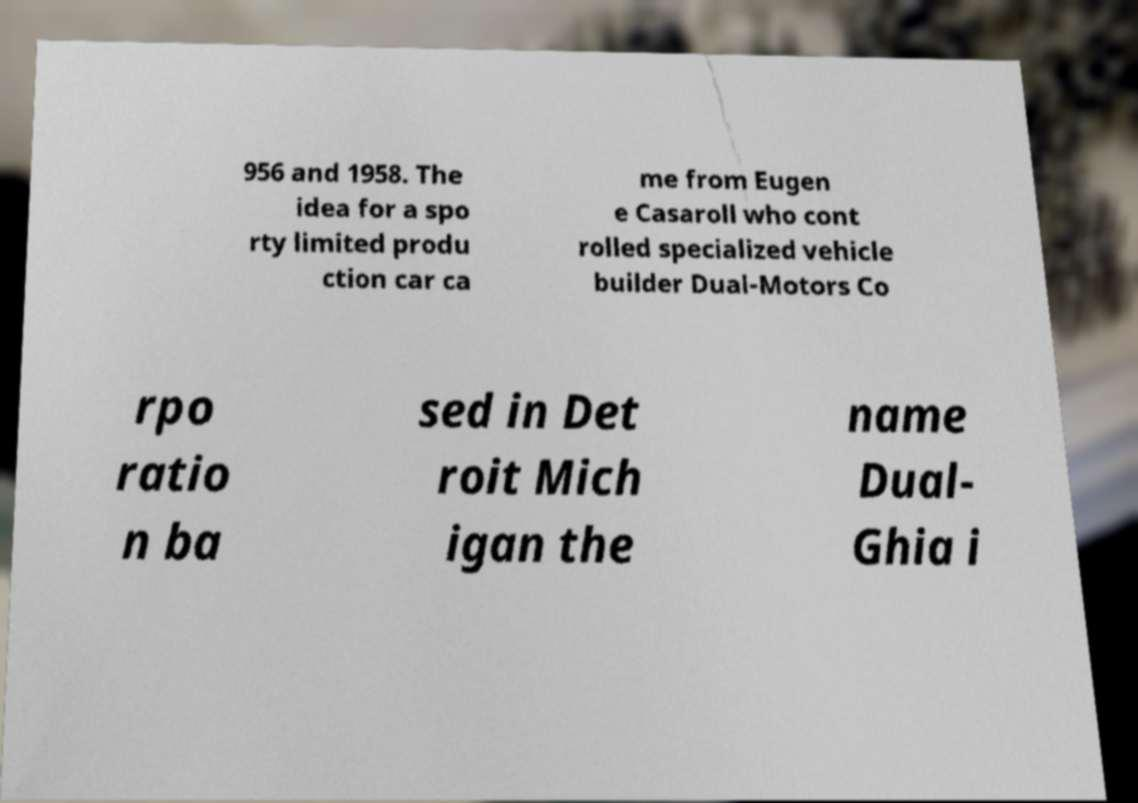I need the written content from this picture converted into text. Can you do that? 956 and 1958. The idea for a spo rty limited produ ction car ca me from Eugen e Casaroll who cont rolled specialized vehicle builder Dual-Motors Co rpo ratio n ba sed in Det roit Mich igan the name Dual- Ghia i 